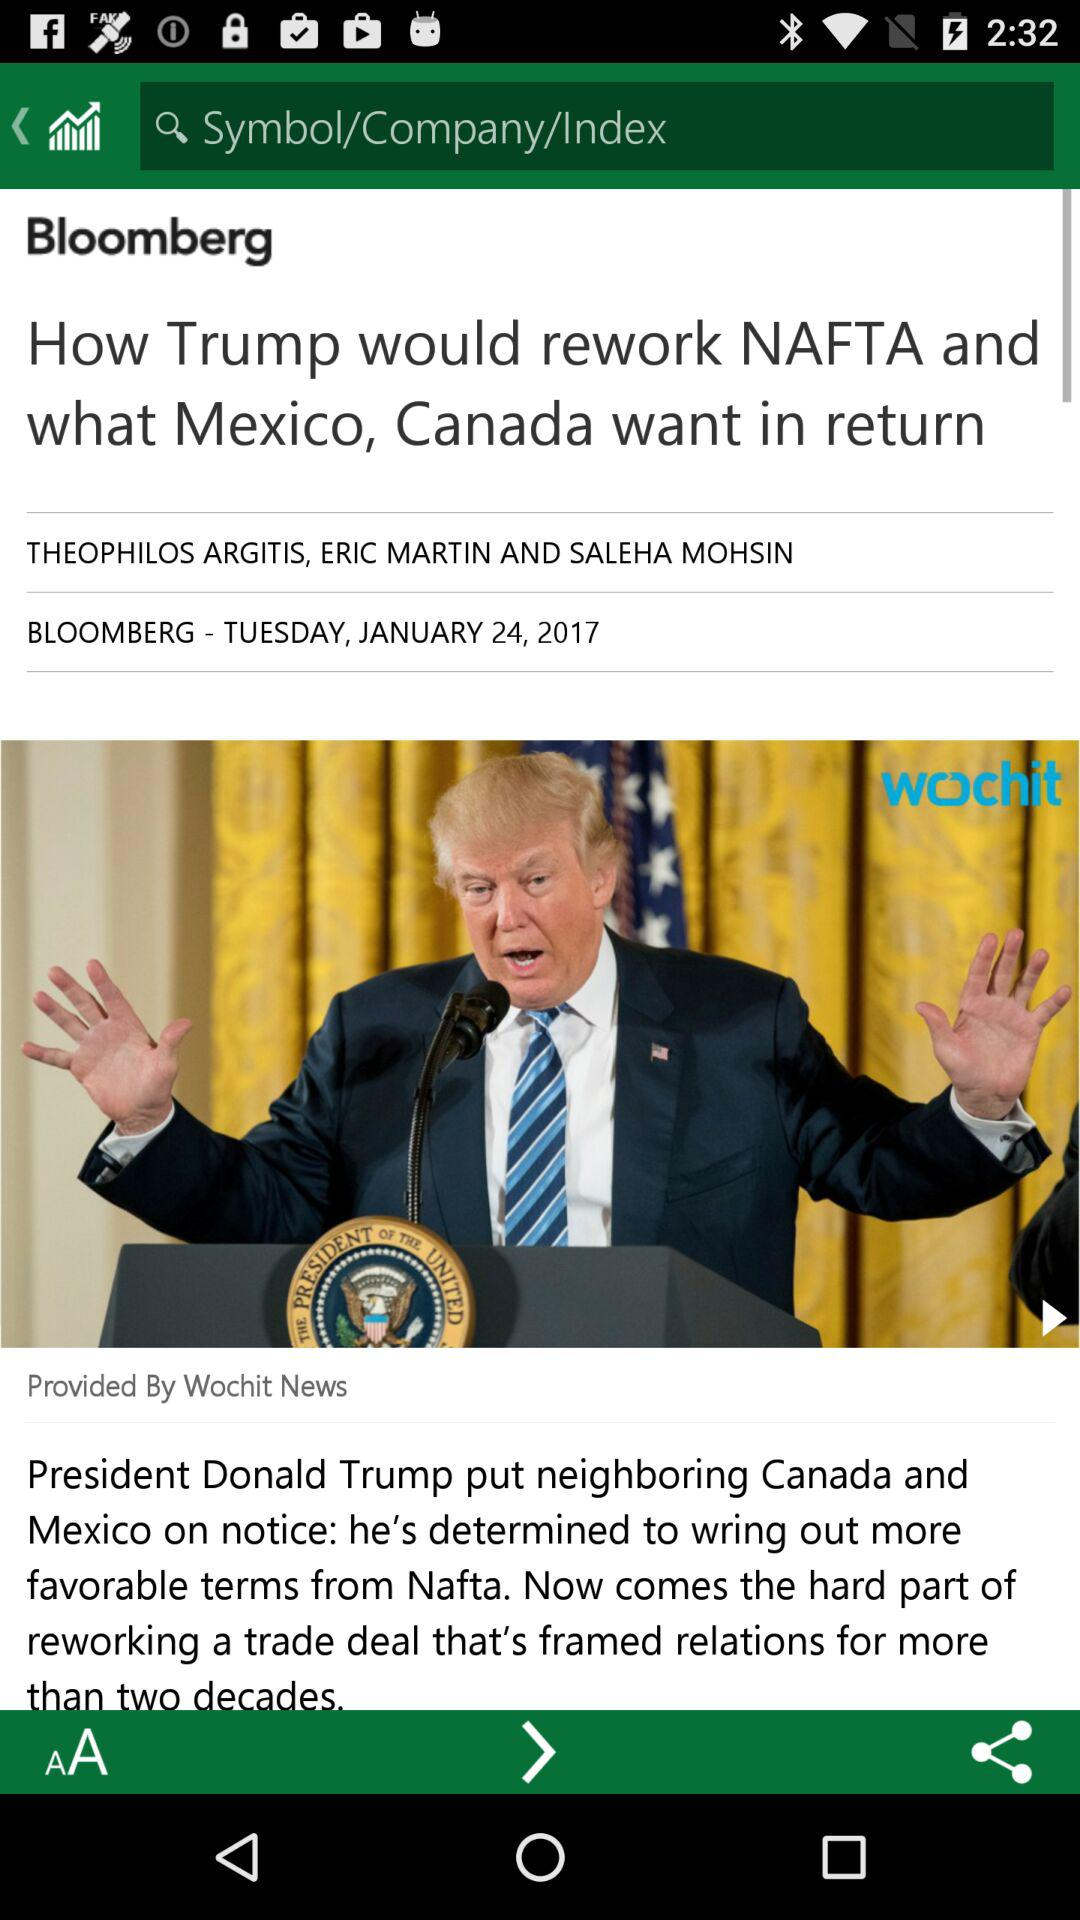At what time was this article published?
When the provided information is insufficient, respond with <no answer>. <no answer> 